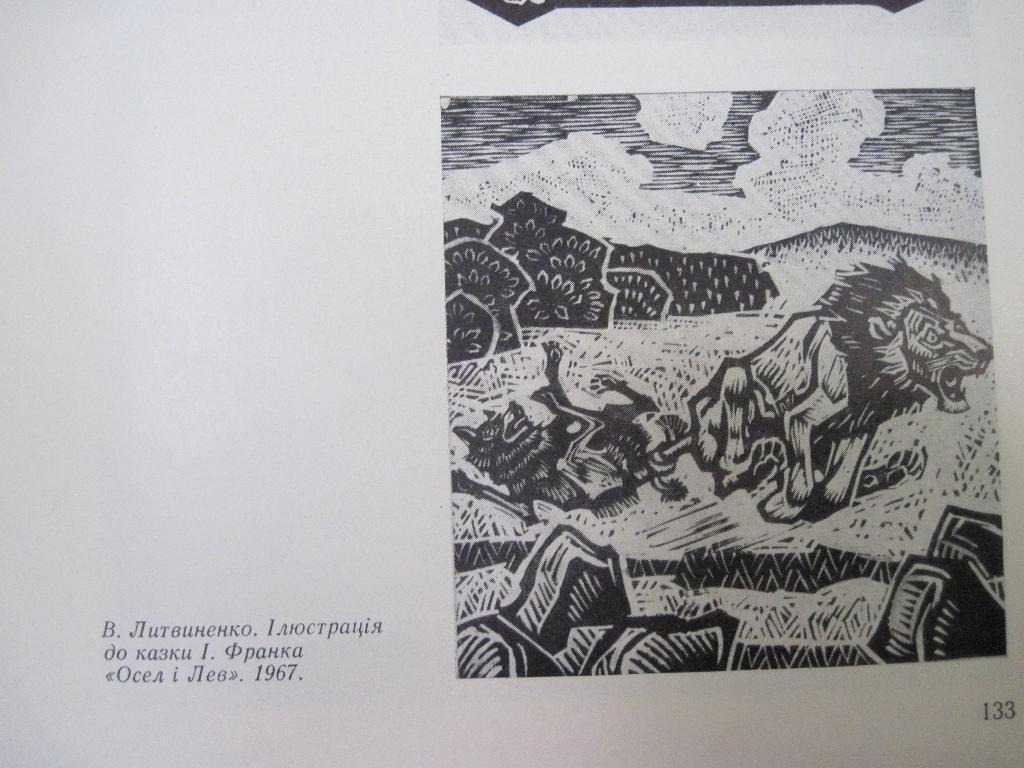What type of visual is depicted in the image? The image appears to be a poster. What can be seen on the right side of the poster? There is a drawing of animals, trees, and the sky on the right side of the poster. What is present on the left side of the poster? There is text on the left side of the poster. What is the aftermath of the flood depicted in the image? There is no depiction of a flood or its aftermath in the image; it features a drawing of animals, trees, and the sky on the right side, and text on the left side. 